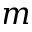<formula> <loc_0><loc_0><loc_500><loc_500>m</formula> 